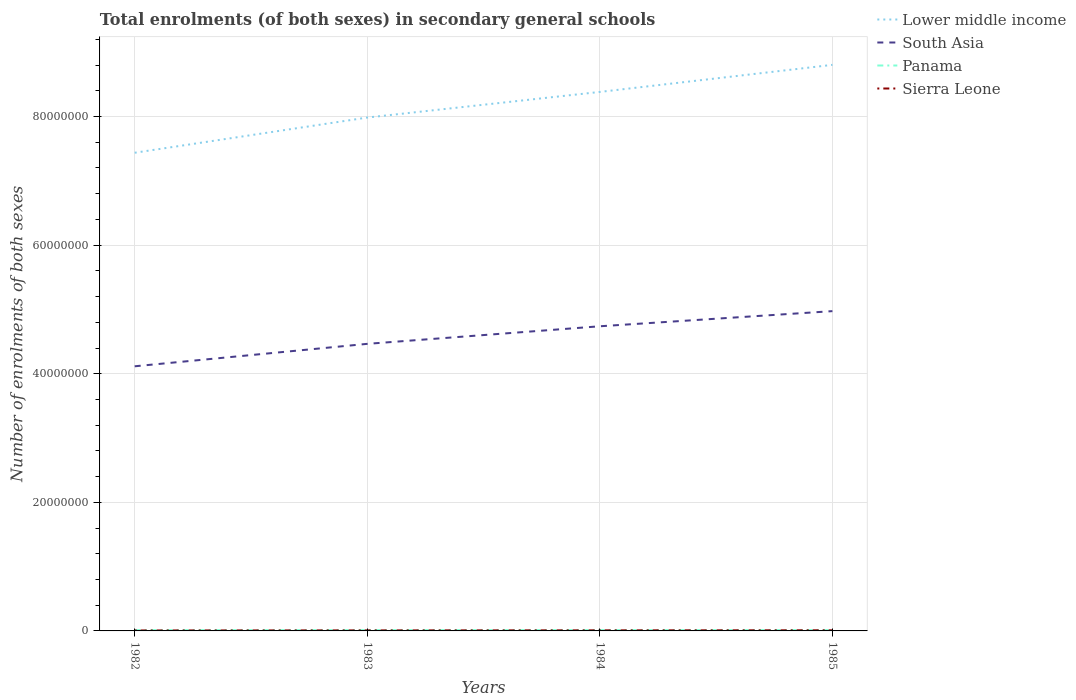Across all years, what is the maximum number of enrolments in secondary schools in Lower middle income?
Your response must be concise. 7.44e+07. In which year was the number of enrolments in secondary schools in Panama maximum?
Provide a succinct answer. 1982. What is the total number of enrolments in secondary schools in Lower middle income in the graph?
Provide a short and direct response. -1.37e+07. What is the difference between the highest and the second highest number of enrolments in secondary schools in Lower middle income?
Ensure brevity in your answer.  1.37e+07. What is the difference between the highest and the lowest number of enrolments in secondary schools in Sierra Leone?
Offer a very short reply. 2. Is the number of enrolments in secondary schools in South Asia strictly greater than the number of enrolments in secondary schools in Sierra Leone over the years?
Offer a very short reply. No. How many years are there in the graph?
Your response must be concise. 4. What is the difference between two consecutive major ticks on the Y-axis?
Make the answer very short. 2.00e+07. Does the graph contain any zero values?
Make the answer very short. No. Where does the legend appear in the graph?
Offer a terse response. Top right. What is the title of the graph?
Your answer should be compact. Total enrolments (of both sexes) in secondary general schools. Does "Lebanon" appear as one of the legend labels in the graph?
Provide a short and direct response. No. What is the label or title of the Y-axis?
Your response must be concise. Number of enrolments of both sexes. What is the Number of enrolments of both sexes of Lower middle income in 1982?
Your answer should be compact. 7.44e+07. What is the Number of enrolments of both sexes of South Asia in 1982?
Make the answer very short. 4.12e+07. What is the Number of enrolments of both sexes of Panama in 1982?
Provide a short and direct response. 1.29e+05. What is the Number of enrolments of both sexes of Sierra Leone in 1982?
Offer a very short reply. 7.24e+04. What is the Number of enrolments of both sexes of Lower middle income in 1983?
Your response must be concise. 7.98e+07. What is the Number of enrolments of both sexes of South Asia in 1983?
Your answer should be compact. 4.46e+07. What is the Number of enrolments of both sexes of Panama in 1983?
Your answer should be very brief. 1.30e+05. What is the Number of enrolments of both sexes of Sierra Leone in 1983?
Your answer should be very brief. 8.18e+04. What is the Number of enrolments of both sexes in Lower middle income in 1984?
Your answer should be very brief. 8.38e+07. What is the Number of enrolments of both sexes in South Asia in 1984?
Offer a very short reply. 4.74e+07. What is the Number of enrolments of both sexes of Panama in 1984?
Ensure brevity in your answer.  1.33e+05. What is the Number of enrolments of both sexes of Sierra Leone in 1984?
Offer a terse response. 8.91e+04. What is the Number of enrolments of both sexes in Lower middle income in 1985?
Provide a short and direct response. 8.80e+07. What is the Number of enrolments of both sexes in South Asia in 1985?
Make the answer very short. 4.97e+07. What is the Number of enrolments of both sexes of Panama in 1985?
Offer a very short reply. 1.34e+05. What is the Number of enrolments of both sexes of Sierra Leone in 1985?
Provide a short and direct response. 9.71e+04. Across all years, what is the maximum Number of enrolments of both sexes of Lower middle income?
Ensure brevity in your answer.  8.80e+07. Across all years, what is the maximum Number of enrolments of both sexes in South Asia?
Your answer should be compact. 4.97e+07. Across all years, what is the maximum Number of enrolments of both sexes in Panama?
Make the answer very short. 1.34e+05. Across all years, what is the maximum Number of enrolments of both sexes in Sierra Leone?
Ensure brevity in your answer.  9.71e+04. Across all years, what is the minimum Number of enrolments of both sexes in Lower middle income?
Give a very brief answer. 7.44e+07. Across all years, what is the minimum Number of enrolments of both sexes in South Asia?
Give a very brief answer. 4.12e+07. Across all years, what is the minimum Number of enrolments of both sexes in Panama?
Make the answer very short. 1.29e+05. Across all years, what is the minimum Number of enrolments of both sexes in Sierra Leone?
Offer a very short reply. 7.24e+04. What is the total Number of enrolments of both sexes in Lower middle income in the graph?
Ensure brevity in your answer.  3.26e+08. What is the total Number of enrolments of both sexes of South Asia in the graph?
Your answer should be very brief. 1.83e+08. What is the total Number of enrolments of both sexes of Panama in the graph?
Give a very brief answer. 5.27e+05. What is the total Number of enrolments of both sexes in Sierra Leone in the graph?
Provide a succinct answer. 3.40e+05. What is the difference between the Number of enrolments of both sexes in Lower middle income in 1982 and that in 1983?
Make the answer very short. -5.48e+06. What is the difference between the Number of enrolments of both sexes in South Asia in 1982 and that in 1983?
Provide a short and direct response. -3.49e+06. What is the difference between the Number of enrolments of both sexes of Panama in 1982 and that in 1983?
Keep it short and to the point. -710. What is the difference between the Number of enrolments of both sexes in Sierra Leone in 1982 and that in 1983?
Make the answer very short. -9392. What is the difference between the Number of enrolments of both sexes of Lower middle income in 1982 and that in 1984?
Give a very brief answer. -9.46e+06. What is the difference between the Number of enrolments of both sexes in South Asia in 1982 and that in 1984?
Make the answer very short. -6.22e+06. What is the difference between the Number of enrolments of both sexes of Panama in 1982 and that in 1984?
Provide a short and direct response. -3920. What is the difference between the Number of enrolments of both sexes of Sierra Leone in 1982 and that in 1984?
Your response must be concise. -1.68e+04. What is the difference between the Number of enrolments of both sexes of Lower middle income in 1982 and that in 1985?
Provide a succinct answer. -1.37e+07. What is the difference between the Number of enrolments of both sexes in South Asia in 1982 and that in 1985?
Make the answer very short. -8.58e+06. What is the difference between the Number of enrolments of both sexes in Panama in 1982 and that in 1985?
Keep it short and to the point. -5267. What is the difference between the Number of enrolments of both sexes of Sierra Leone in 1982 and that in 1985?
Your response must be concise. -2.48e+04. What is the difference between the Number of enrolments of both sexes of Lower middle income in 1983 and that in 1984?
Your answer should be compact. -3.98e+06. What is the difference between the Number of enrolments of both sexes of South Asia in 1983 and that in 1984?
Keep it short and to the point. -2.73e+06. What is the difference between the Number of enrolments of both sexes of Panama in 1983 and that in 1984?
Your response must be concise. -3210. What is the difference between the Number of enrolments of both sexes in Sierra Leone in 1983 and that in 1984?
Give a very brief answer. -7358. What is the difference between the Number of enrolments of both sexes of Lower middle income in 1983 and that in 1985?
Keep it short and to the point. -8.19e+06. What is the difference between the Number of enrolments of both sexes in South Asia in 1983 and that in 1985?
Keep it short and to the point. -5.09e+06. What is the difference between the Number of enrolments of both sexes of Panama in 1983 and that in 1985?
Provide a succinct answer. -4557. What is the difference between the Number of enrolments of both sexes of Sierra Leone in 1983 and that in 1985?
Make the answer very short. -1.54e+04. What is the difference between the Number of enrolments of both sexes of Lower middle income in 1984 and that in 1985?
Give a very brief answer. -4.21e+06. What is the difference between the Number of enrolments of both sexes of South Asia in 1984 and that in 1985?
Keep it short and to the point. -2.36e+06. What is the difference between the Number of enrolments of both sexes of Panama in 1984 and that in 1985?
Offer a very short reply. -1347. What is the difference between the Number of enrolments of both sexes of Sierra Leone in 1984 and that in 1985?
Keep it short and to the point. -8020. What is the difference between the Number of enrolments of both sexes of Lower middle income in 1982 and the Number of enrolments of both sexes of South Asia in 1983?
Provide a short and direct response. 2.97e+07. What is the difference between the Number of enrolments of both sexes of Lower middle income in 1982 and the Number of enrolments of both sexes of Panama in 1983?
Provide a succinct answer. 7.42e+07. What is the difference between the Number of enrolments of both sexes in Lower middle income in 1982 and the Number of enrolments of both sexes in Sierra Leone in 1983?
Your answer should be very brief. 7.43e+07. What is the difference between the Number of enrolments of both sexes of South Asia in 1982 and the Number of enrolments of both sexes of Panama in 1983?
Provide a succinct answer. 4.10e+07. What is the difference between the Number of enrolments of both sexes of South Asia in 1982 and the Number of enrolments of both sexes of Sierra Leone in 1983?
Provide a succinct answer. 4.11e+07. What is the difference between the Number of enrolments of both sexes of Panama in 1982 and the Number of enrolments of both sexes of Sierra Leone in 1983?
Offer a terse response. 4.74e+04. What is the difference between the Number of enrolments of both sexes in Lower middle income in 1982 and the Number of enrolments of both sexes in South Asia in 1984?
Make the answer very short. 2.70e+07. What is the difference between the Number of enrolments of both sexes in Lower middle income in 1982 and the Number of enrolments of both sexes in Panama in 1984?
Your response must be concise. 7.42e+07. What is the difference between the Number of enrolments of both sexes of Lower middle income in 1982 and the Number of enrolments of both sexes of Sierra Leone in 1984?
Give a very brief answer. 7.43e+07. What is the difference between the Number of enrolments of both sexes in South Asia in 1982 and the Number of enrolments of both sexes in Panama in 1984?
Provide a succinct answer. 4.10e+07. What is the difference between the Number of enrolments of both sexes in South Asia in 1982 and the Number of enrolments of both sexes in Sierra Leone in 1984?
Offer a very short reply. 4.11e+07. What is the difference between the Number of enrolments of both sexes in Panama in 1982 and the Number of enrolments of both sexes in Sierra Leone in 1984?
Your answer should be very brief. 4.01e+04. What is the difference between the Number of enrolments of both sexes of Lower middle income in 1982 and the Number of enrolments of both sexes of South Asia in 1985?
Provide a short and direct response. 2.46e+07. What is the difference between the Number of enrolments of both sexes of Lower middle income in 1982 and the Number of enrolments of both sexes of Panama in 1985?
Your answer should be compact. 7.42e+07. What is the difference between the Number of enrolments of both sexes of Lower middle income in 1982 and the Number of enrolments of both sexes of Sierra Leone in 1985?
Your response must be concise. 7.43e+07. What is the difference between the Number of enrolments of both sexes in South Asia in 1982 and the Number of enrolments of both sexes in Panama in 1985?
Provide a succinct answer. 4.10e+07. What is the difference between the Number of enrolments of both sexes of South Asia in 1982 and the Number of enrolments of both sexes of Sierra Leone in 1985?
Ensure brevity in your answer.  4.11e+07. What is the difference between the Number of enrolments of both sexes in Panama in 1982 and the Number of enrolments of both sexes in Sierra Leone in 1985?
Provide a short and direct response. 3.21e+04. What is the difference between the Number of enrolments of both sexes in Lower middle income in 1983 and the Number of enrolments of both sexes in South Asia in 1984?
Provide a succinct answer. 3.25e+07. What is the difference between the Number of enrolments of both sexes in Lower middle income in 1983 and the Number of enrolments of both sexes in Panama in 1984?
Keep it short and to the point. 7.97e+07. What is the difference between the Number of enrolments of both sexes in Lower middle income in 1983 and the Number of enrolments of both sexes in Sierra Leone in 1984?
Provide a short and direct response. 7.98e+07. What is the difference between the Number of enrolments of both sexes of South Asia in 1983 and the Number of enrolments of both sexes of Panama in 1984?
Provide a short and direct response. 4.45e+07. What is the difference between the Number of enrolments of both sexes in South Asia in 1983 and the Number of enrolments of both sexes in Sierra Leone in 1984?
Provide a short and direct response. 4.46e+07. What is the difference between the Number of enrolments of both sexes in Panama in 1983 and the Number of enrolments of both sexes in Sierra Leone in 1984?
Keep it short and to the point. 4.08e+04. What is the difference between the Number of enrolments of both sexes in Lower middle income in 1983 and the Number of enrolments of both sexes in South Asia in 1985?
Your response must be concise. 3.01e+07. What is the difference between the Number of enrolments of both sexes in Lower middle income in 1983 and the Number of enrolments of both sexes in Panama in 1985?
Offer a very short reply. 7.97e+07. What is the difference between the Number of enrolments of both sexes in Lower middle income in 1983 and the Number of enrolments of both sexes in Sierra Leone in 1985?
Give a very brief answer. 7.97e+07. What is the difference between the Number of enrolments of both sexes of South Asia in 1983 and the Number of enrolments of both sexes of Panama in 1985?
Keep it short and to the point. 4.45e+07. What is the difference between the Number of enrolments of both sexes in South Asia in 1983 and the Number of enrolments of both sexes in Sierra Leone in 1985?
Ensure brevity in your answer.  4.46e+07. What is the difference between the Number of enrolments of both sexes of Panama in 1983 and the Number of enrolments of both sexes of Sierra Leone in 1985?
Your answer should be compact. 3.28e+04. What is the difference between the Number of enrolments of both sexes of Lower middle income in 1984 and the Number of enrolments of both sexes of South Asia in 1985?
Give a very brief answer. 3.41e+07. What is the difference between the Number of enrolments of both sexes in Lower middle income in 1984 and the Number of enrolments of both sexes in Panama in 1985?
Your response must be concise. 8.37e+07. What is the difference between the Number of enrolments of both sexes in Lower middle income in 1984 and the Number of enrolments of both sexes in Sierra Leone in 1985?
Provide a short and direct response. 8.37e+07. What is the difference between the Number of enrolments of both sexes in South Asia in 1984 and the Number of enrolments of both sexes in Panama in 1985?
Ensure brevity in your answer.  4.72e+07. What is the difference between the Number of enrolments of both sexes in South Asia in 1984 and the Number of enrolments of both sexes in Sierra Leone in 1985?
Your answer should be compact. 4.73e+07. What is the difference between the Number of enrolments of both sexes in Panama in 1984 and the Number of enrolments of both sexes in Sierra Leone in 1985?
Offer a terse response. 3.60e+04. What is the average Number of enrolments of both sexes of Lower middle income per year?
Keep it short and to the point. 8.15e+07. What is the average Number of enrolments of both sexes of South Asia per year?
Provide a short and direct response. 4.57e+07. What is the average Number of enrolments of both sexes of Panama per year?
Give a very brief answer. 1.32e+05. What is the average Number of enrolments of both sexes in Sierra Leone per year?
Offer a very short reply. 8.51e+04. In the year 1982, what is the difference between the Number of enrolments of both sexes of Lower middle income and Number of enrolments of both sexes of South Asia?
Your answer should be very brief. 3.32e+07. In the year 1982, what is the difference between the Number of enrolments of both sexes of Lower middle income and Number of enrolments of both sexes of Panama?
Make the answer very short. 7.42e+07. In the year 1982, what is the difference between the Number of enrolments of both sexes of Lower middle income and Number of enrolments of both sexes of Sierra Leone?
Make the answer very short. 7.43e+07. In the year 1982, what is the difference between the Number of enrolments of both sexes of South Asia and Number of enrolments of both sexes of Panama?
Ensure brevity in your answer.  4.10e+07. In the year 1982, what is the difference between the Number of enrolments of both sexes of South Asia and Number of enrolments of both sexes of Sierra Leone?
Offer a terse response. 4.11e+07. In the year 1982, what is the difference between the Number of enrolments of both sexes in Panama and Number of enrolments of both sexes in Sierra Leone?
Your answer should be very brief. 5.68e+04. In the year 1983, what is the difference between the Number of enrolments of both sexes of Lower middle income and Number of enrolments of both sexes of South Asia?
Your response must be concise. 3.52e+07. In the year 1983, what is the difference between the Number of enrolments of both sexes in Lower middle income and Number of enrolments of both sexes in Panama?
Make the answer very short. 7.97e+07. In the year 1983, what is the difference between the Number of enrolments of both sexes in Lower middle income and Number of enrolments of both sexes in Sierra Leone?
Your answer should be compact. 7.98e+07. In the year 1983, what is the difference between the Number of enrolments of both sexes in South Asia and Number of enrolments of both sexes in Panama?
Make the answer very short. 4.45e+07. In the year 1983, what is the difference between the Number of enrolments of both sexes in South Asia and Number of enrolments of both sexes in Sierra Leone?
Your answer should be very brief. 4.46e+07. In the year 1983, what is the difference between the Number of enrolments of both sexes in Panama and Number of enrolments of both sexes in Sierra Leone?
Provide a succinct answer. 4.82e+04. In the year 1984, what is the difference between the Number of enrolments of both sexes of Lower middle income and Number of enrolments of both sexes of South Asia?
Keep it short and to the point. 3.64e+07. In the year 1984, what is the difference between the Number of enrolments of both sexes of Lower middle income and Number of enrolments of both sexes of Panama?
Ensure brevity in your answer.  8.37e+07. In the year 1984, what is the difference between the Number of enrolments of both sexes of Lower middle income and Number of enrolments of both sexes of Sierra Leone?
Provide a short and direct response. 8.37e+07. In the year 1984, what is the difference between the Number of enrolments of both sexes in South Asia and Number of enrolments of both sexes in Panama?
Make the answer very short. 4.72e+07. In the year 1984, what is the difference between the Number of enrolments of both sexes in South Asia and Number of enrolments of both sexes in Sierra Leone?
Keep it short and to the point. 4.73e+07. In the year 1984, what is the difference between the Number of enrolments of both sexes of Panama and Number of enrolments of both sexes of Sierra Leone?
Ensure brevity in your answer.  4.40e+04. In the year 1985, what is the difference between the Number of enrolments of both sexes of Lower middle income and Number of enrolments of both sexes of South Asia?
Provide a short and direct response. 3.83e+07. In the year 1985, what is the difference between the Number of enrolments of both sexes in Lower middle income and Number of enrolments of both sexes in Panama?
Your response must be concise. 8.79e+07. In the year 1985, what is the difference between the Number of enrolments of both sexes of Lower middle income and Number of enrolments of both sexes of Sierra Leone?
Make the answer very short. 8.79e+07. In the year 1985, what is the difference between the Number of enrolments of both sexes of South Asia and Number of enrolments of both sexes of Panama?
Your answer should be compact. 4.96e+07. In the year 1985, what is the difference between the Number of enrolments of both sexes in South Asia and Number of enrolments of both sexes in Sierra Leone?
Ensure brevity in your answer.  4.96e+07. In the year 1985, what is the difference between the Number of enrolments of both sexes of Panama and Number of enrolments of both sexes of Sierra Leone?
Your answer should be very brief. 3.73e+04. What is the ratio of the Number of enrolments of both sexes in Lower middle income in 1982 to that in 1983?
Ensure brevity in your answer.  0.93. What is the ratio of the Number of enrolments of both sexes in South Asia in 1982 to that in 1983?
Your response must be concise. 0.92. What is the ratio of the Number of enrolments of both sexes of Sierra Leone in 1982 to that in 1983?
Make the answer very short. 0.89. What is the ratio of the Number of enrolments of both sexes of Lower middle income in 1982 to that in 1984?
Your answer should be very brief. 0.89. What is the ratio of the Number of enrolments of both sexes in South Asia in 1982 to that in 1984?
Make the answer very short. 0.87. What is the ratio of the Number of enrolments of both sexes in Panama in 1982 to that in 1984?
Keep it short and to the point. 0.97. What is the ratio of the Number of enrolments of both sexes in Sierra Leone in 1982 to that in 1984?
Give a very brief answer. 0.81. What is the ratio of the Number of enrolments of both sexes in Lower middle income in 1982 to that in 1985?
Give a very brief answer. 0.84. What is the ratio of the Number of enrolments of both sexes in South Asia in 1982 to that in 1985?
Your response must be concise. 0.83. What is the ratio of the Number of enrolments of both sexes of Panama in 1982 to that in 1985?
Give a very brief answer. 0.96. What is the ratio of the Number of enrolments of both sexes of Sierra Leone in 1982 to that in 1985?
Offer a terse response. 0.74. What is the ratio of the Number of enrolments of both sexes of Lower middle income in 1983 to that in 1984?
Make the answer very short. 0.95. What is the ratio of the Number of enrolments of both sexes of South Asia in 1983 to that in 1984?
Ensure brevity in your answer.  0.94. What is the ratio of the Number of enrolments of both sexes of Panama in 1983 to that in 1984?
Your response must be concise. 0.98. What is the ratio of the Number of enrolments of both sexes of Sierra Leone in 1983 to that in 1984?
Keep it short and to the point. 0.92. What is the ratio of the Number of enrolments of both sexes in Lower middle income in 1983 to that in 1985?
Your answer should be compact. 0.91. What is the ratio of the Number of enrolments of both sexes of South Asia in 1983 to that in 1985?
Give a very brief answer. 0.9. What is the ratio of the Number of enrolments of both sexes in Panama in 1983 to that in 1985?
Ensure brevity in your answer.  0.97. What is the ratio of the Number of enrolments of both sexes in Sierra Leone in 1983 to that in 1985?
Your answer should be very brief. 0.84. What is the ratio of the Number of enrolments of both sexes of Lower middle income in 1984 to that in 1985?
Your answer should be compact. 0.95. What is the ratio of the Number of enrolments of both sexes in South Asia in 1984 to that in 1985?
Offer a terse response. 0.95. What is the ratio of the Number of enrolments of both sexes of Panama in 1984 to that in 1985?
Make the answer very short. 0.99. What is the ratio of the Number of enrolments of both sexes of Sierra Leone in 1984 to that in 1985?
Ensure brevity in your answer.  0.92. What is the difference between the highest and the second highest Number of enrolments of both sexes of Lower middle income?
Provide a succinct answer. 4.21e+06. What is the difference between the highest and the second highest Number of enrolments of both sexes of South Asia?
Ensure brevity in your answer.  2.36e+06. What is the difference between the highest and the second highest Number of enrolments of both sexes of Panama?
Offer a terse response. 1347. What is the difference between the highest and the second highest Number of enrolments of both sexes in Sierra Leone?
Offer a terse response. 8020. What is the difference between the highest and the lowest Number of enrolments of both sexes in Lower middle income?
Offer a terse response. 1.37e+07. What is the difference between the highest and the lowest Number of enrolments of both sexes of South Asia?
Offer a terse response. 8.58e+06. What is the difference between the highest and the lowest Number of enrolments of both sexes of Panama?
Your answer should be very brief. 5267. What is the difference between the highest and the lowest Number of enrolments of both sexes of Sierra Leone?
Your response must be concise. 2.48e+04. 